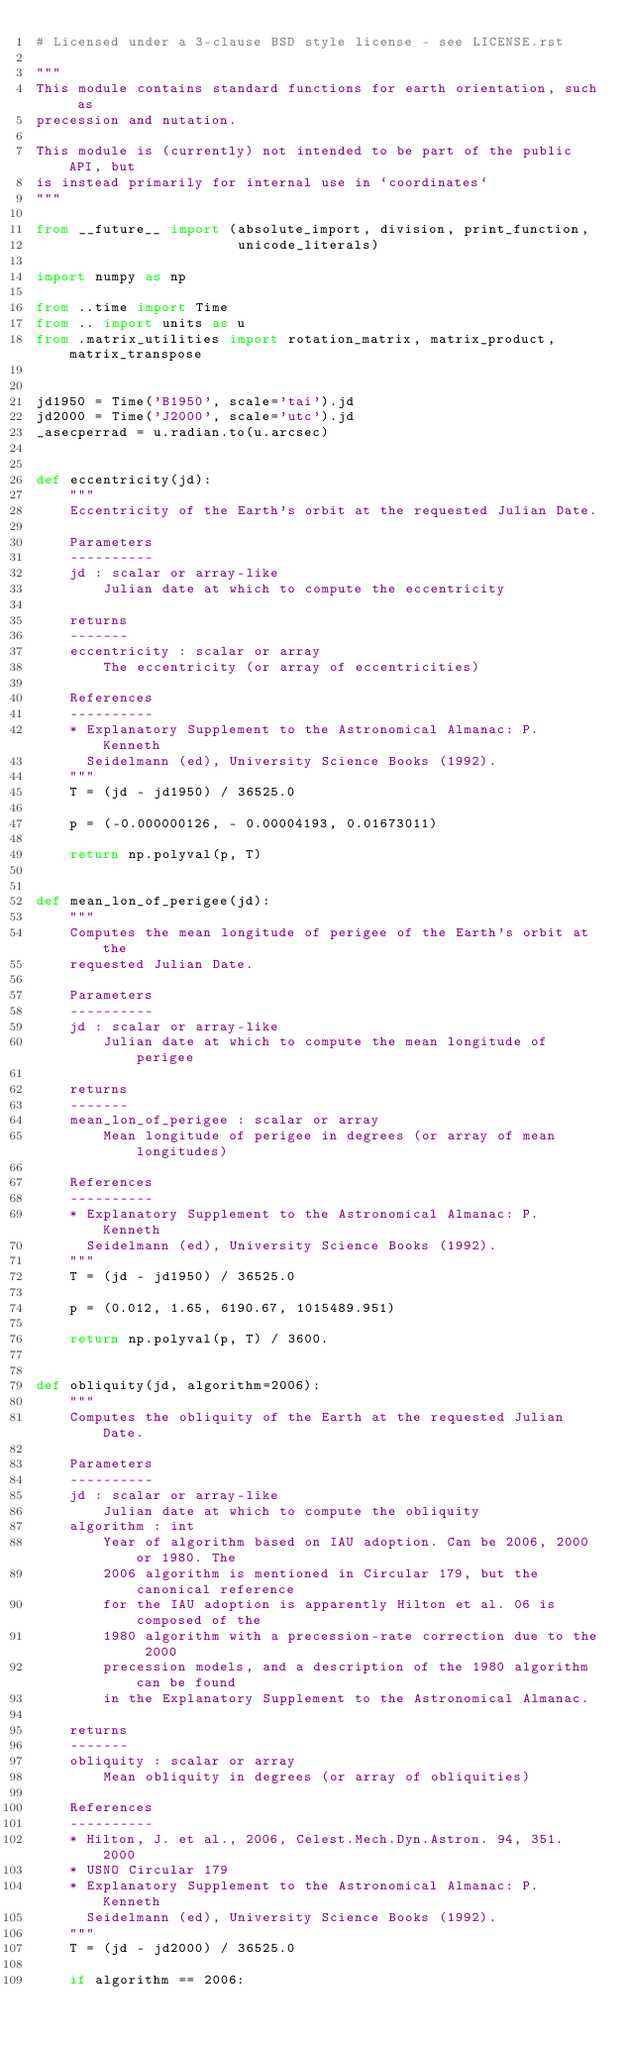<code> <loc_0><loc_0><loc_500><loc_500><_Python_># Licensed under a 3-clause BSD style license - see LICENSE.rst

"""
This module contains standard functions for earth orientation, such as
precession and nutation.

This module is (currently) not intended to be part of the public API, but
is instead primarily for internal use in `coordinates`
"""

from __future__ import (absolute_import, division, print_function,
                        unicode_literals)

import numpy as np

from ..time import Time
from .. import units as u
from .matrix_utilities import rotation_matrix, matrix_product, matrix_transpose


jd1950 = Time('B1950', scale='tai').jd
jd2000 = Time('J2000', scale='utc').jd
_asecperrad = u.radian.to(u.arcsec)


def eccentricity(jd):
    """
    Eccentricity of the Earth's orbit at the requested Julian Date.

    Parameters
    ----------
    jd : scalar or array-like
        Julian date at which to compute the eccentricity

    returns
    -------
    eccentricity : scalar or array
        The eccentricity (or array of eccentricities)

    References
    ----------
    * Explanatory Supplement to the Astronomical Almanac: P. Kenneth
      Seidelmann (ed), University Science Books (1992).
    """
    T = (jd - jd1950) / 36525.0

    p = (-0.000000126, - 0.00004193, 0.01673011)

    return np.polyval(p, T)


def mean_lon_of_perigee(jd):
    """
    Computes the mean longitude of perigee of the Earth's orbit at the
    requested Julian Date.

    Parameters
    ----------
    jd : scalar or array-like
        Julian date at which to compute the mean longitude of perigee

    returns
    -------
    mean_lon_of_perigee : scalar or array
        Mean longitude of perigee in degrees (or array of mean longitudes)

    References
    ----------
    * Explanatory Supplement to the Astronomical Almanac: P. Kenneth
      Seidelmann (ed), University Science Books (1992).
    """
    T = (jd - jd1950) / 36525.0

    p = (0.012, 1.65, 6190.67, 1015489.951)

    return np.polyval(p, T) / 3600.


def obliquity(jd, algorithm=2006):
    """
    Computes the obliquity of the Earth at the requested Julian Date.

    Parameters
    ----------
    jd : scalar or array-like
        Julian date at which to compute the obliquity
    algorithm : int
        Year of algorithm based on IAU adoption. Can be 2006, 2000 or 1980. The
        2006 algorithm is mentioned in Circular 179, but the canonical reference
        for the IAU adoption is apparently Hilton et al. 06 is composed of the
        1980 algorithm with a precession-rate correction due to the 2000
        precession models, and a description of the 1980 algorithm can be found
        in the Explanatory Supplement to the Astronomical Almanac.

    returns
    -------
    obliquity : scalar or array
        Mean obliquity in degrees (or array of obliquities)

    References
    ----------
    * Hilton, J. et al., 2006, Celest.Mech.Dyn.Astron. 94, 351. 2000
    * USNO Circular 179
    * Explanatory Supplement to the Astronomical Almanac: P. Kenneth
      Seidelmann (ed), University Science Books (1992).
    """
    T = (jd - jd2000) / 36525.0

    if algorithm == 2006:</code> 